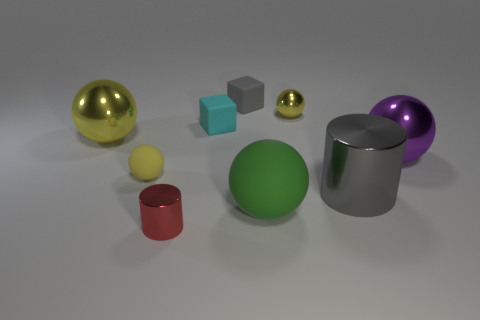Does the large purple object have the same shape as the large thing that is in front of the large gray metallic object?
Give a very brief answer. Yes. Is there a small cyan matte thing?
Your response must be concise. Yes. What number of large objects are either purple shiny cubes or green rubber objects?
Provide a succinct answer. 1. Are there more big objects that are to the left of the tiny cyan thing than yellow rubber objects that are behind the purple metallic thing?
Give a very brief answer. Yes. Is the material of the tiny cylinder the same as the small ball to the right of the tiny red metal object?
Offer a terse response. Yes. What color is the small metal sphere?
Offer a very short reply. Yellow. The tiny metallic object behind the large purple metal object has what shape?
Provide a succinct answer. Sphere. How many purple objects are either shiny spheres or small metallic spheres?
Your answer should be compact. 1. The other tiny thing that is made of the same material as the red thing is what color?
Your response must be concise. Yellow. Do the tiny shiny ball and the small ball on the left side of the green matte object have the same color?
Keep it short and to the point. Yes. 